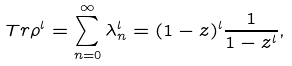<formula> <loc_0><loc_0><loc_500><loc_500>T r \rho ^ { l } = \sum _ { n = 0 } ^ { \infty } \lambda _ { n } ^ { l } = ( 1 - z ) ^ { l } \frac { 1 } { 1 - z ^ { l } } ,</formula> 